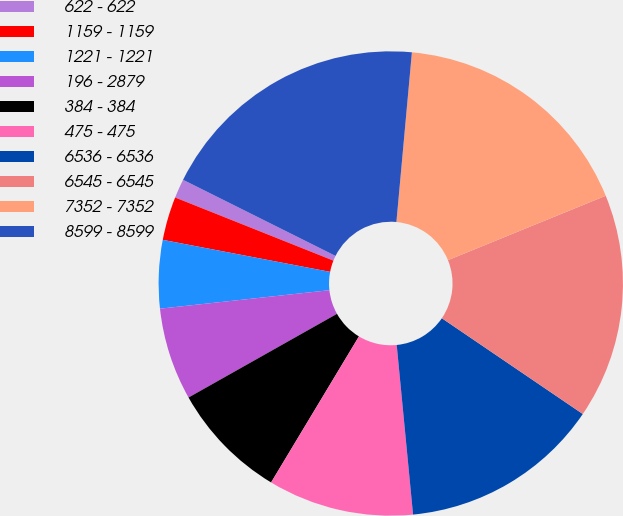Convert chart. <chart><loc_0><loc_0><loc_500><loc_500><pie_chart><fcel>622 - 622<fcel>1159 - 1159<fcel>1221 - 1221<fcel>196 - 2879<fcel>384 - 384<fcel>475 - 475<fcel>6536 - 6536<fcel>6545 - 6545<fcel>7352 - 7352<fcel>8599 - 8599<nl><fcel>1.33%<fcel>3.03%<fcel>4.74%<fcel>6.44%<fcel>8.21%<fcel>10.15%<fcel>13.97%<fcel>15.67%<fcel>17.38%<fcel>19.08%<nl></chart> 